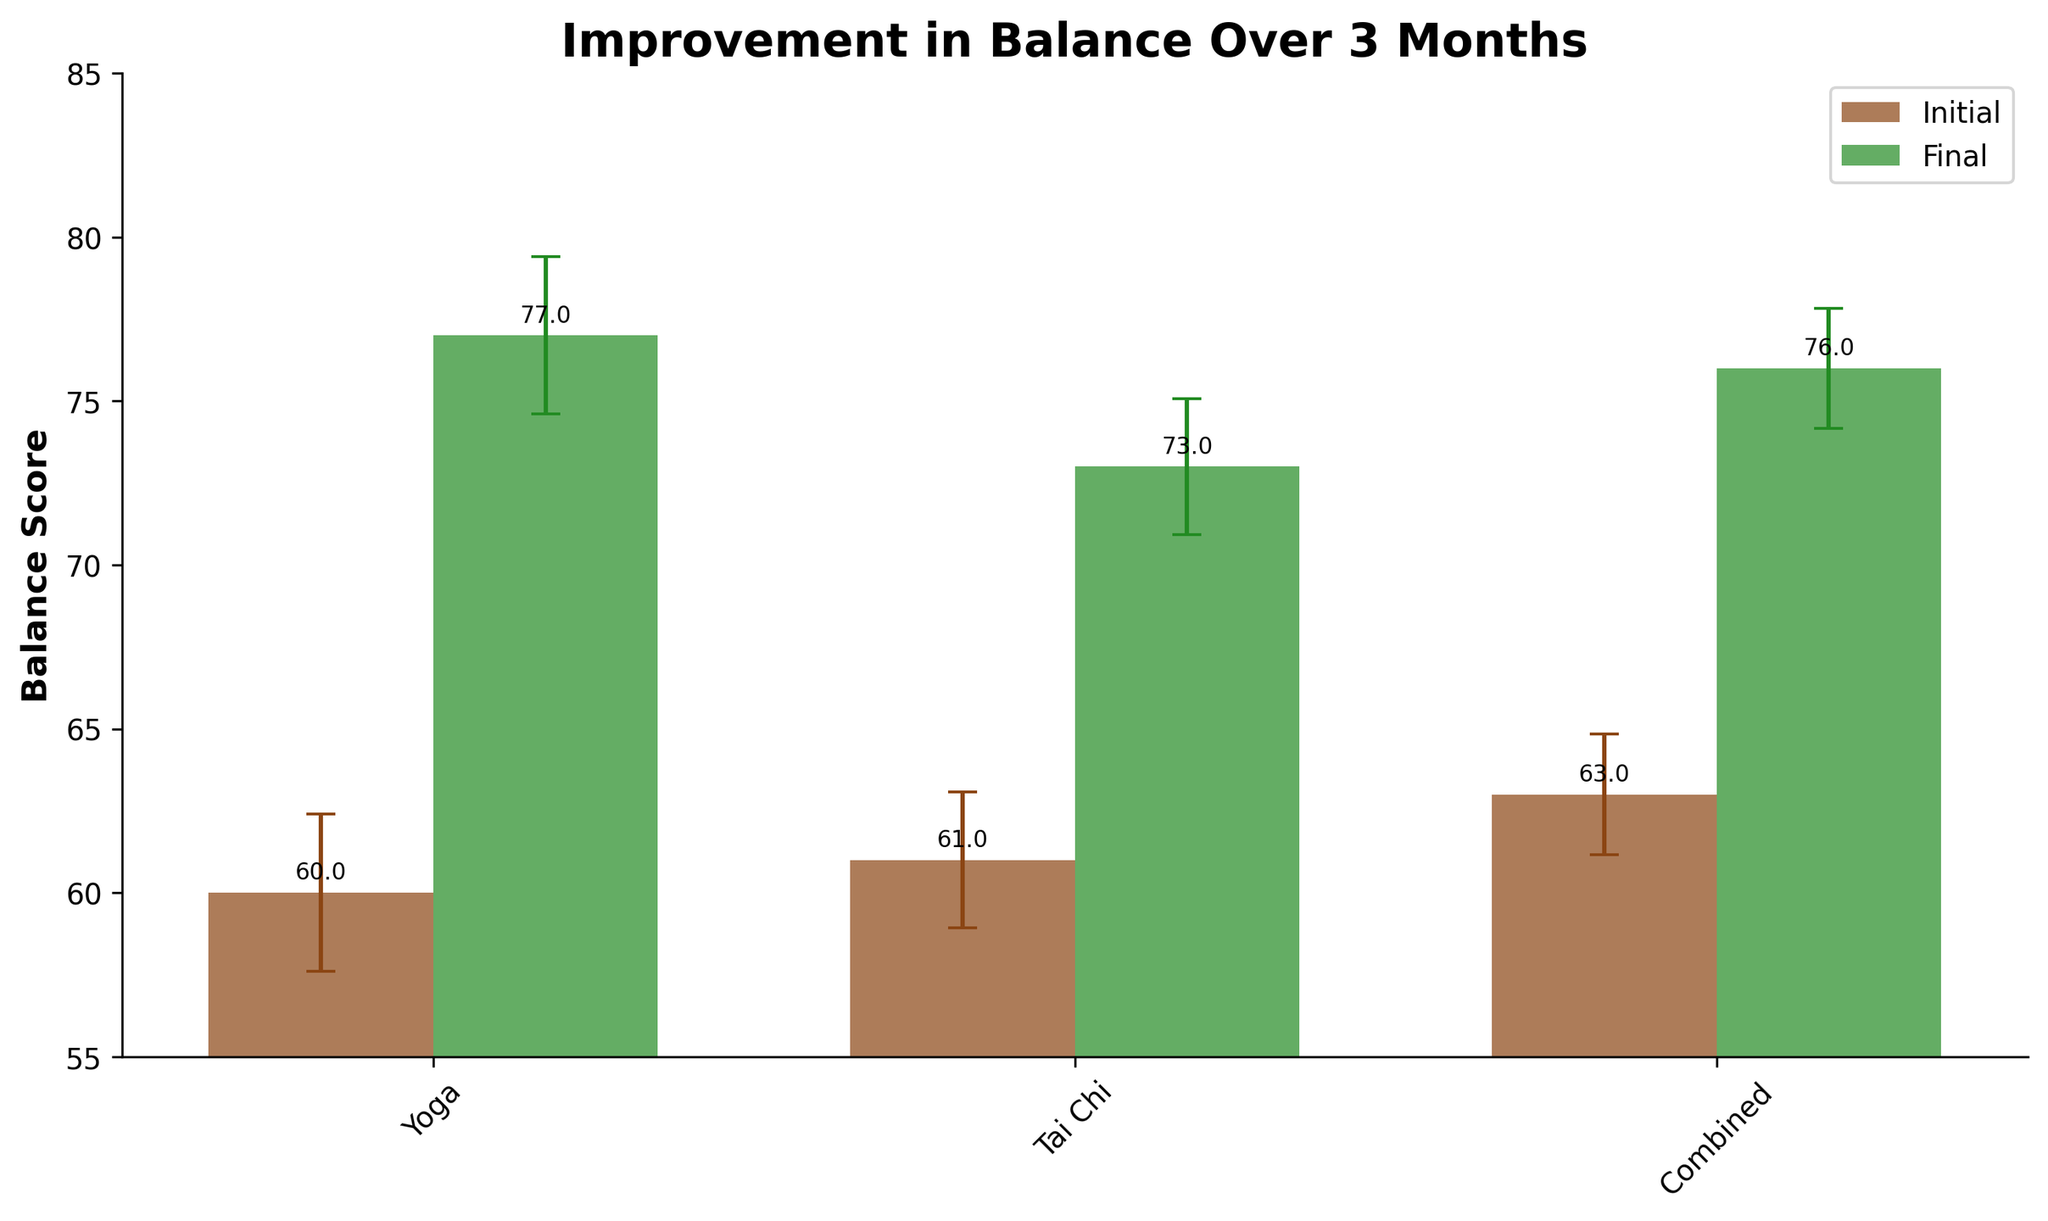What is the title of the figure? The title is usually displayed at the top of the figure. In this case, it reads "Improvement in Balance Over 3 Months".
Answer: Improvement in Balance Over 3 Months What balance score range is shown on the y-axis? Looking at the y-axis, the tick marks range from 55 to 85.
Answer: 55 to 85 How many practice groups are represented in the figure? The x-axis labels represent the practice groups, which includes Yoga, Tai Chi, and Combined.
Answer: 3 Which practice group has the highest final balance score? The tallest green bar in the figure, representing the final balance scores, is associated with the Combined practice group.
Answer: Combined What is the average improvement in balance score for the Tai Chi group over 3 months? Calculate by subtracting the initial average balance score from the final average balance score for Tai Chi. 74 (Final) - 60 (Initial) = 14.
Answer: 14 Which group shows the smallest average improvement in balance score? Compare the differences between final and initial balance scores for all groups. Yoga: 75-63=12, Tai Chi: 74-60=14, Combined: 78-60=18. The Yoga group has the smallest improvement.
Answer: Yoga What color represents the initial balance scores, and what color represents the final balance scores in the figure? The bar colors are distinct for initial and final scores; initial scores are in brown, and final scores are in green.
Answer: Brown for initial, Green for final What is the purpose of the error bars in the figure? Error bars indicate the variability or standard error of the balance scores. They help understand the precision and reliability of the averages presented.
Answer: Indicate standard error Among the groups having error bars, which one has the largest standard error for the final balance score? The length of the error bars above the final balance score bars should be compared. The Combined group shows the largest error bar for final scores and, therefore, the largest standard error.
Answer: Combined By how much does the final balance score for the Combined group exceed that of the Yoga group? Subtract the final balance score of Yoga from Combined. 78 - 75 = 3.
Answer: 3 